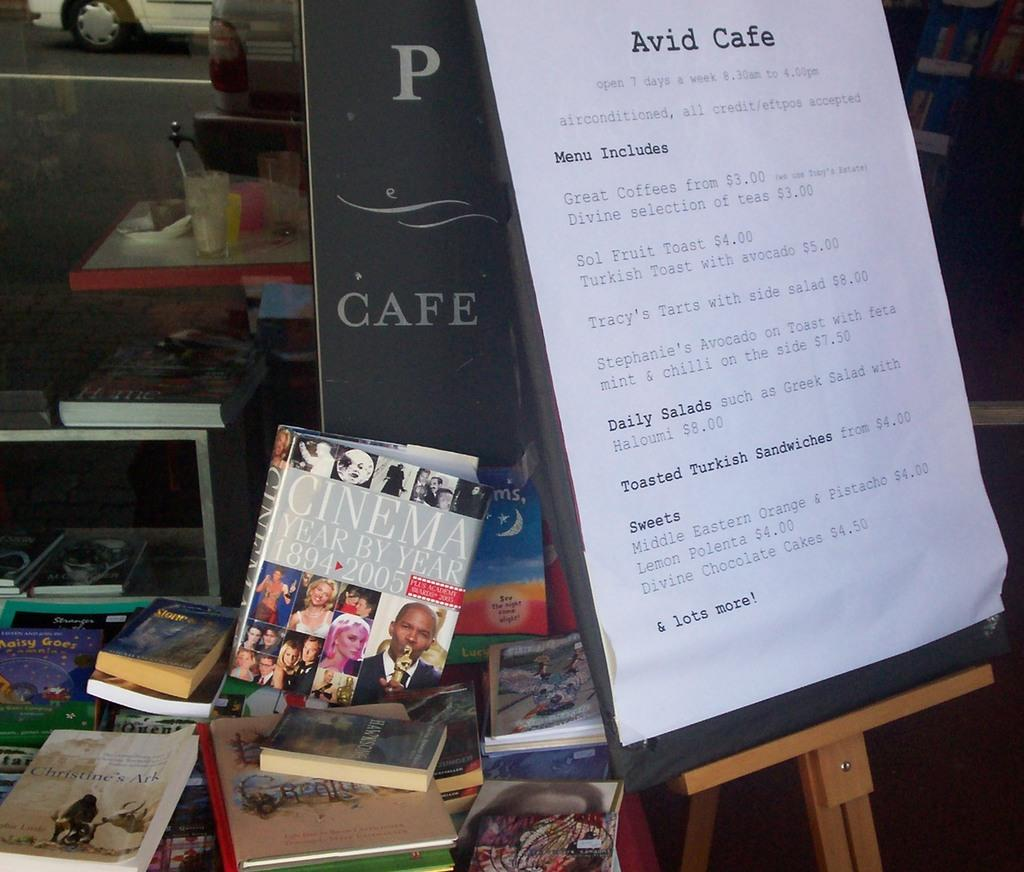<image>
Relay a brief, clear account of the picture shown. A menu for Avid Cafe posted next to a pile of books. 